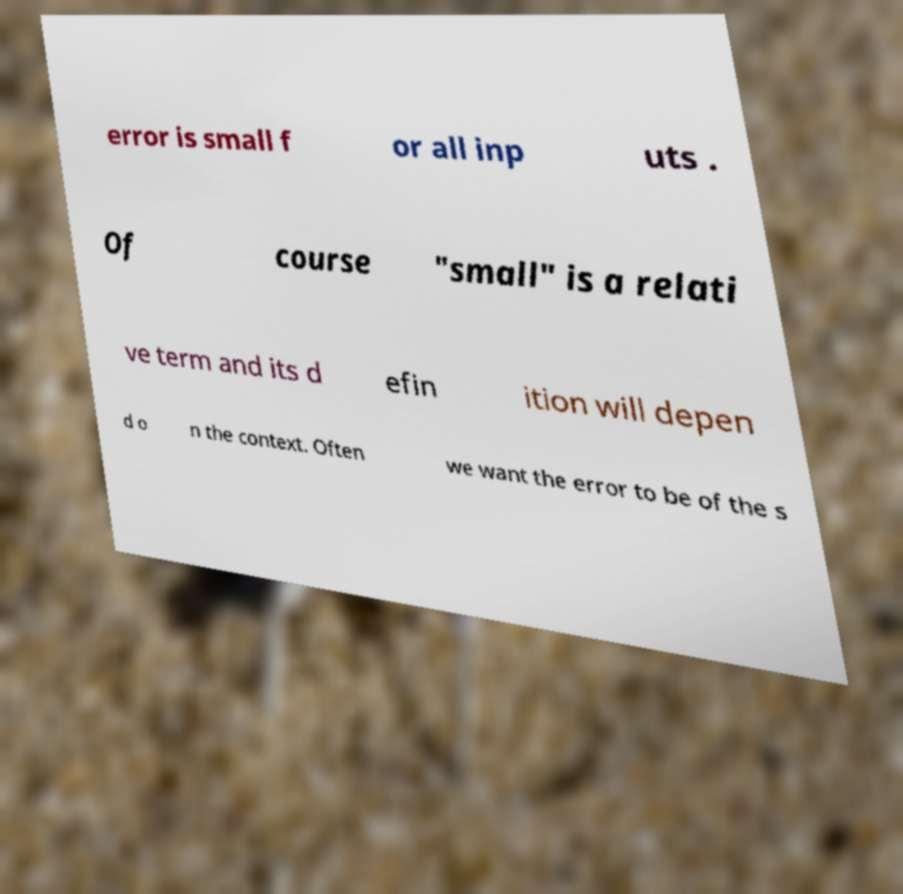Please identify and transcribe the text found in this image. error is small f or all inp uts . Of course "small" is a relati ve term and its d efin ition will depen d o n the context. Often we want the error to be of the s 